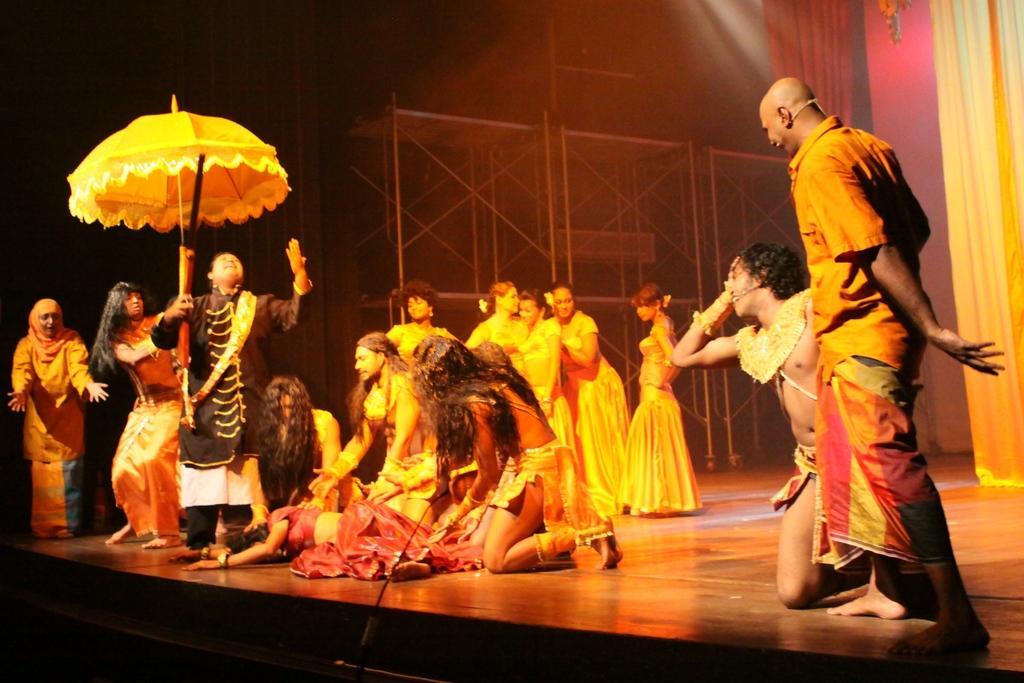How would you summarize this image in a sentence or two? In this image there are a few people playing an act on the stage. In the background there are metal structure and curtains. 